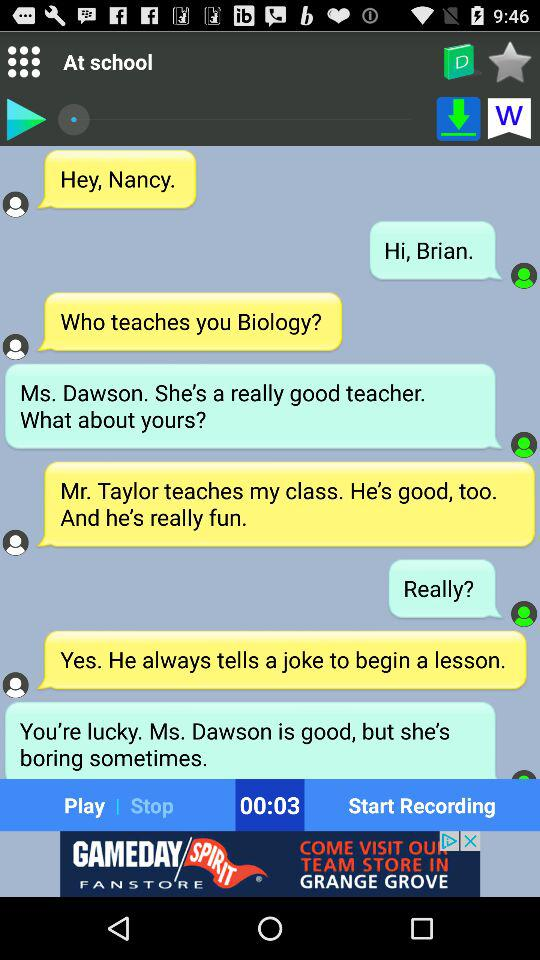What is the duration of the recording? The duration of the recording is 00:03. 